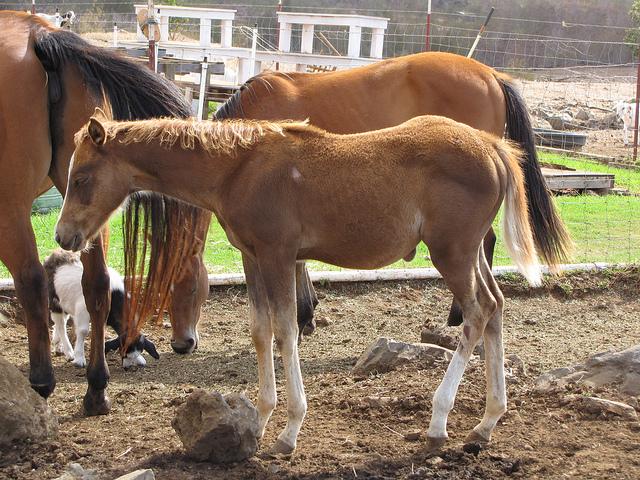Is this an adult horse?
Be succinct. No. How tall is pony?
Give a very brief answer. 3 feet. What is different about the horse in the middle?
Answer briefly. Nothing. Where are the horse's standing?
Short answer required. Dirt. 